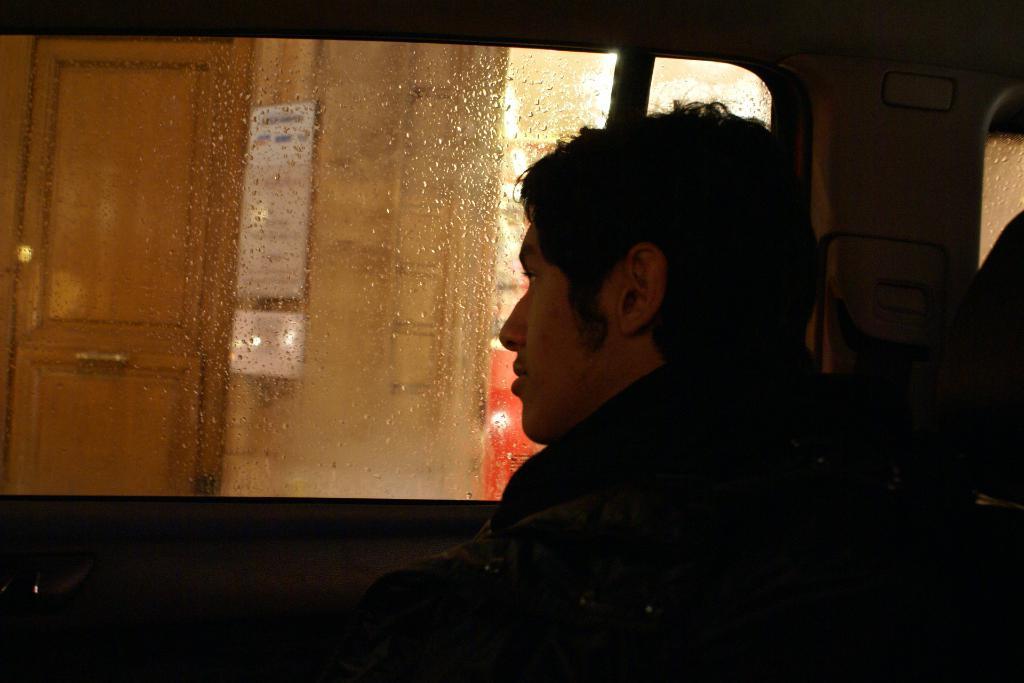Describe this image in one or two sentences. There is a person in black color dress sitting on a vehicle near glass window. There are water drops on the glass. Through this glass, we can see, there is a building which is having wooden door and other objects. 